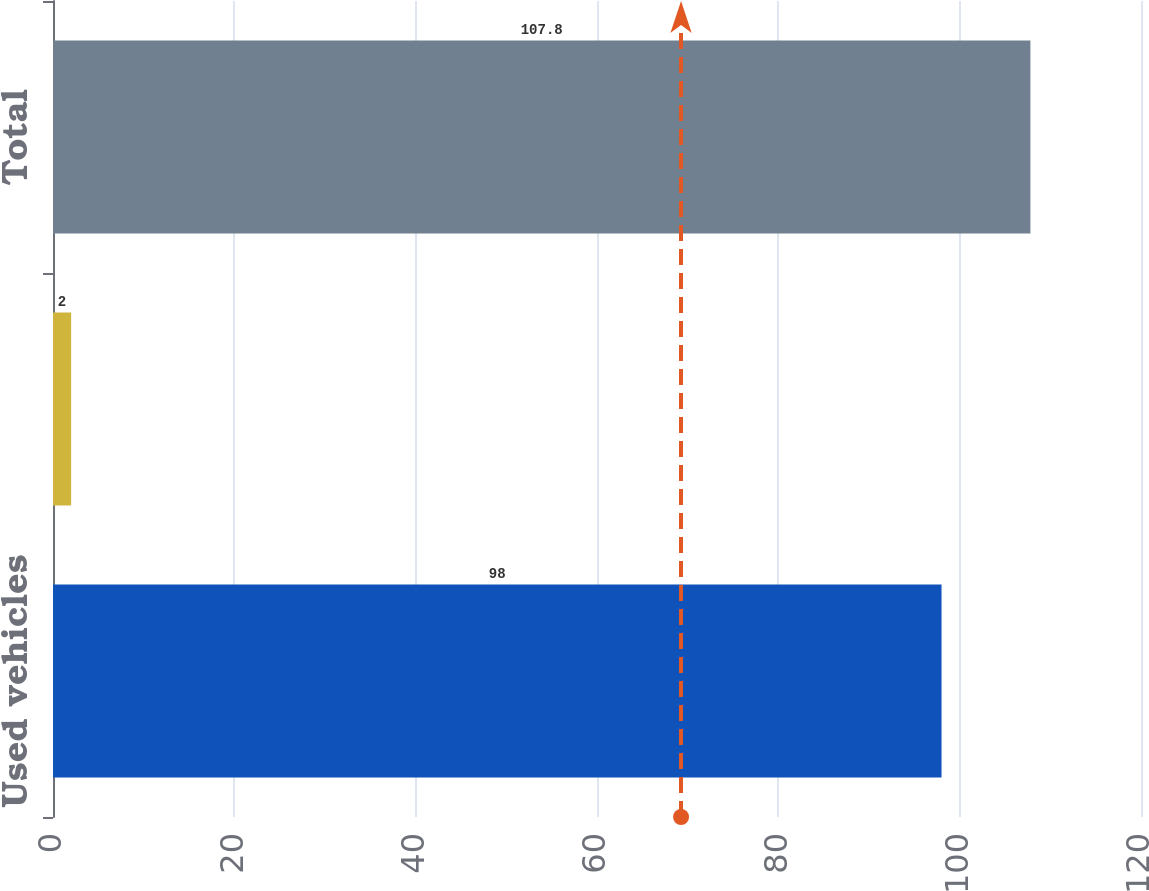Convert chart. <chart><loc_0><loc_0><loc_500><loc_500><bar_chart><fcel>Used vehicles<fcel>New vehicles<fcel>Total<nl><fcel>98<fcel>2<fcel>107.8<nl></chart> 